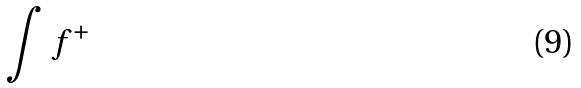Convert formula to latex. <formula><loc_0><loc_0><loc_500><loc_500>\int f ^ { + }</formula> 